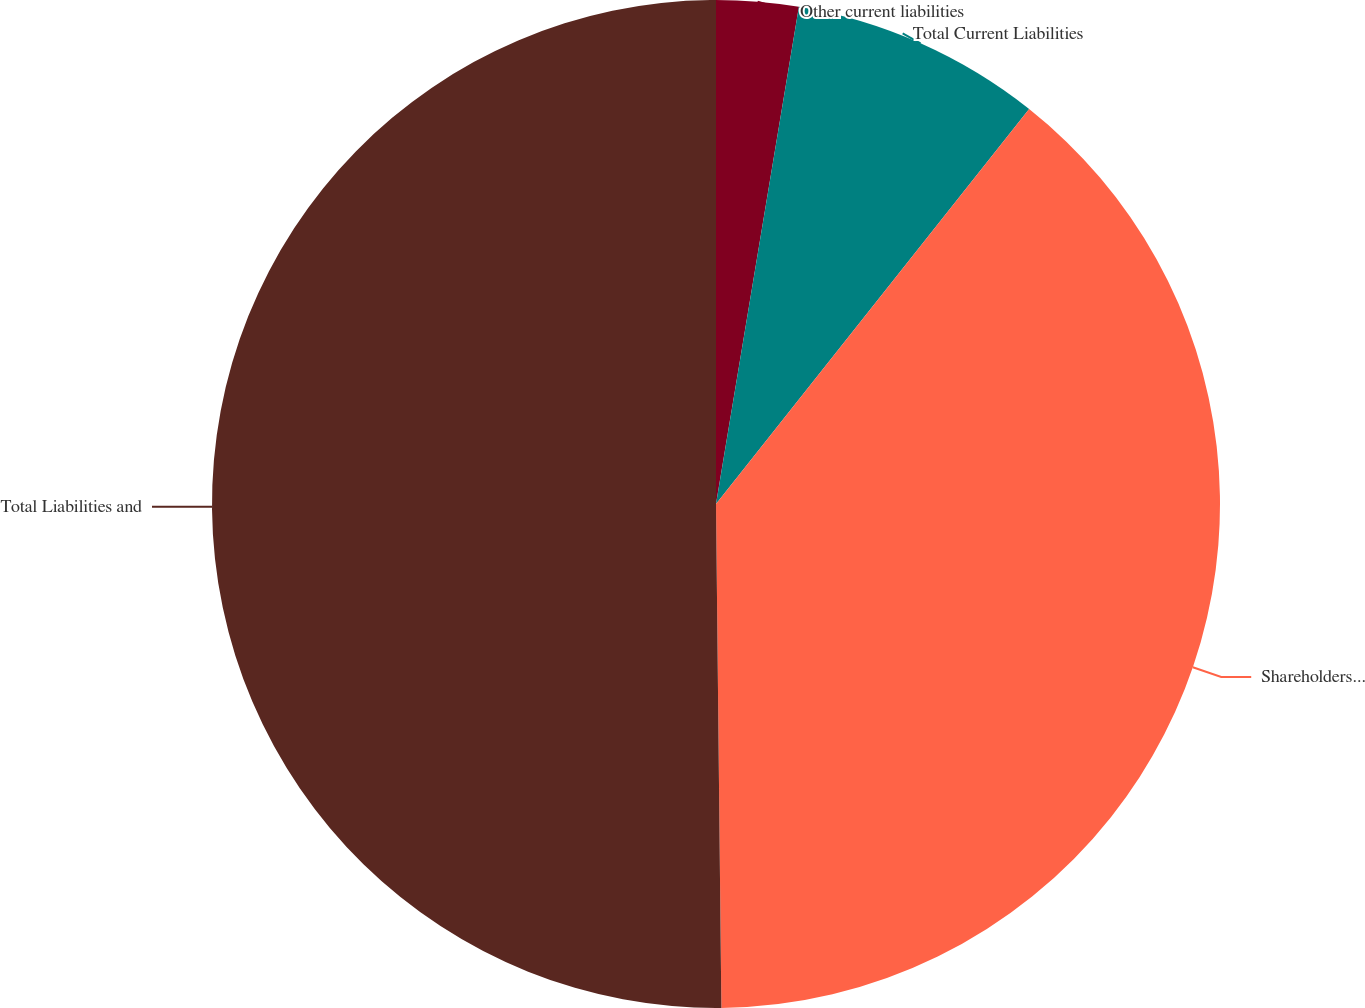Convert chart. <chart><loc_0><loc_0><loc_500><loc_500><pie_chart><fcel>Other current liabilities<fcel>Total Current Liabilities<fcel>Shareholders' Equity<fcel>Total Liabilities and<nl><fcel>2.63%<fcel>8.04%<fcel>39.16%<fcel>50.17%<nl></chart> 